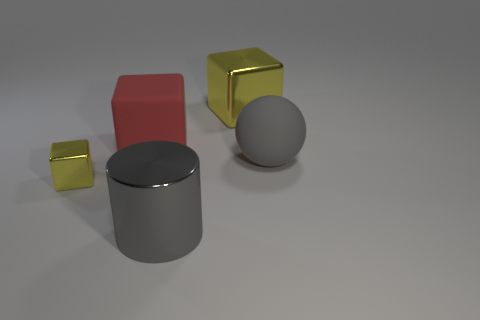What materials do the objects in the image appear to be made of and how do their surfaces reflect light? The objects in the image seem to have a variety of materials. The sphere and cylinder have a rubber and matte appearance, showing diffuse reflections. The small yellow and big red items both appear metallic, with the yellow one having a reflective, shiny surface, while the red cube has a less polished, matte metallic finish. 